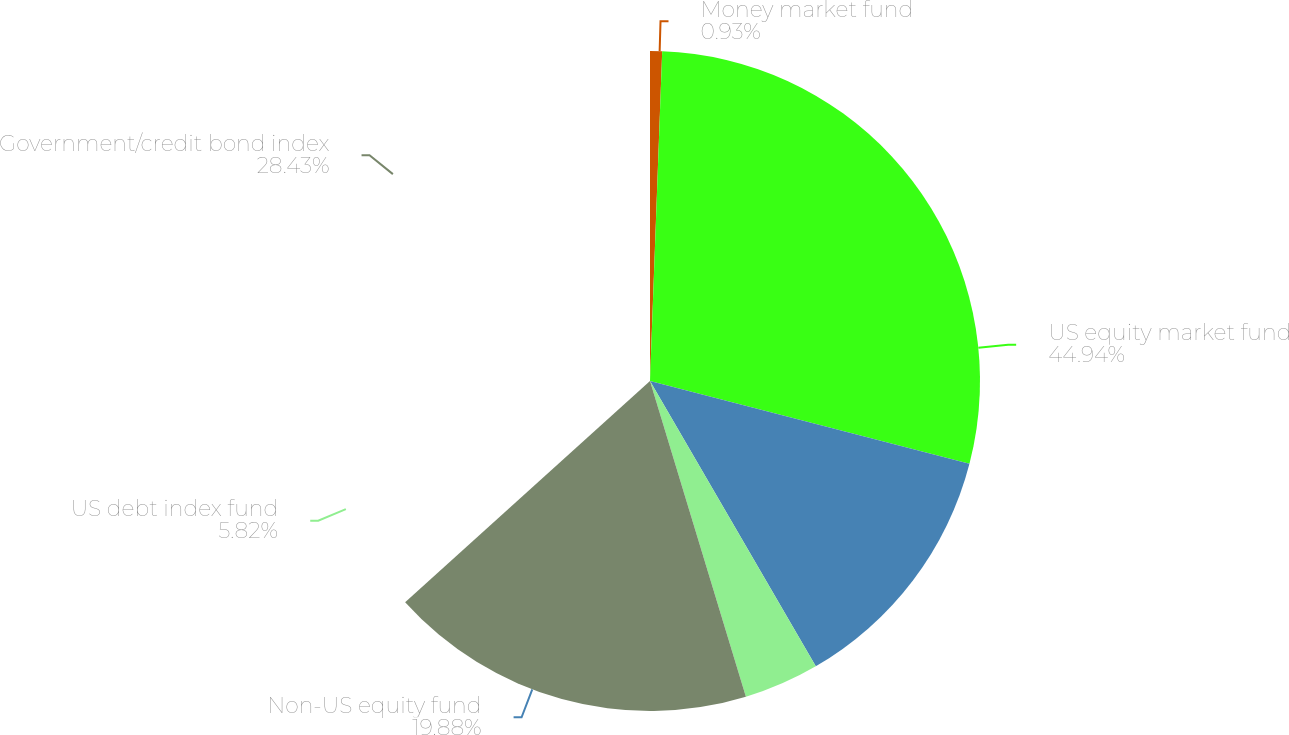Convert chart. <chart><loc_0><loc_0><loc_500><loc_500><pie_chart><fcel>Money market fund<fcel>US equity market fund<fcel>Non-US equity fund<fcel>US debt index fund<fcel>Government/credit bond index<nl><fcel>0.93%<fcel>44.93%<fcel>19.88%<fcel>5.82%<fcel>28.43%<nl></chart> 